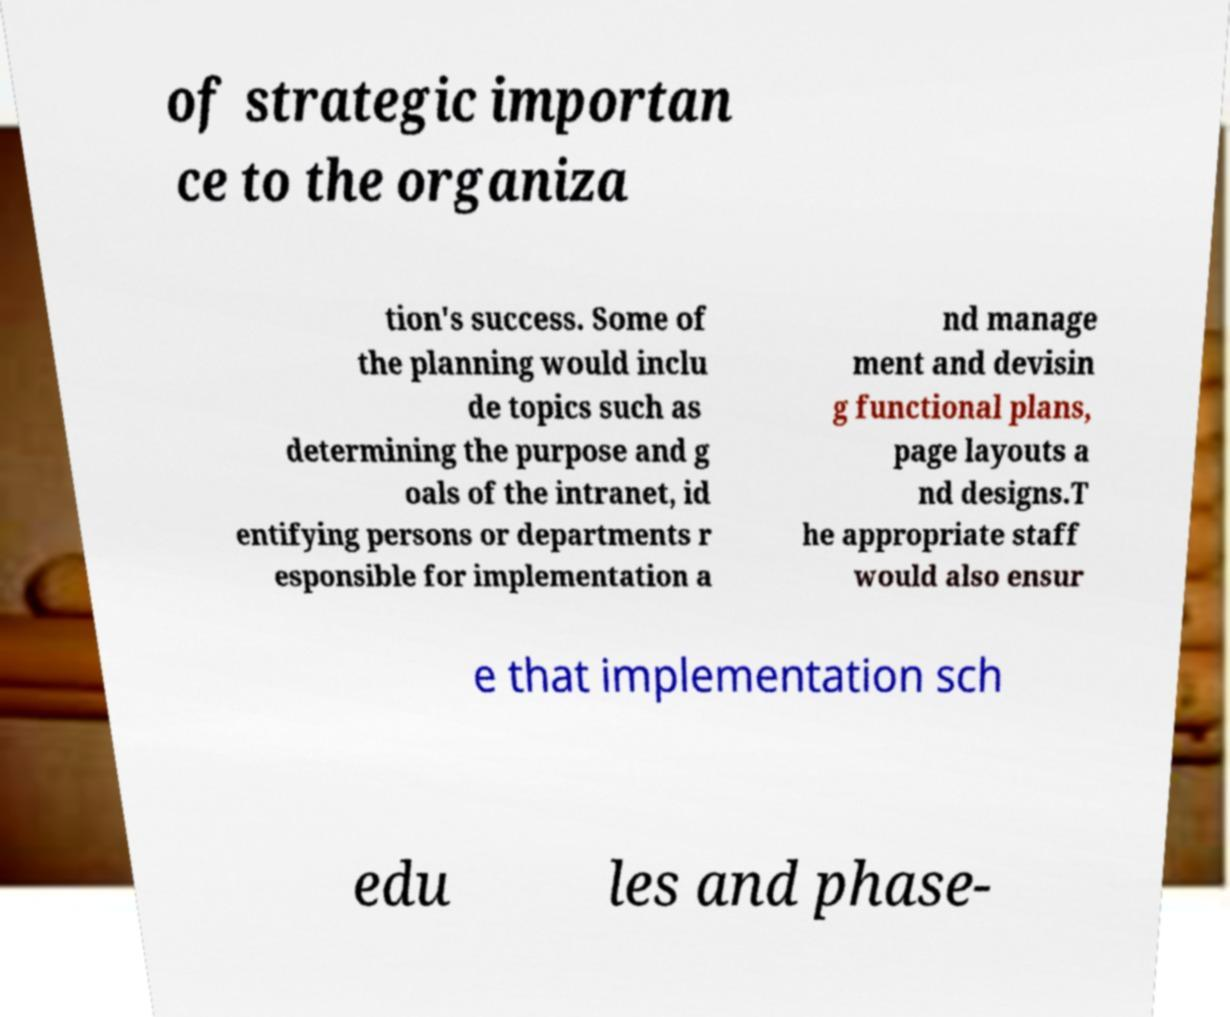Please identify and transcribe the text found in this image. of strategic importan ce to the organiza tion's success. Some of the planning would inclu de topics such as determining the purpose and g oals of the intranet, id entifying persons or departments r esponsible for implementation a nd manage ment and devisin g functional plans, page layouts a nd designs.T he appropriate staff would also ensur e that implementation sch edu les and phase- 